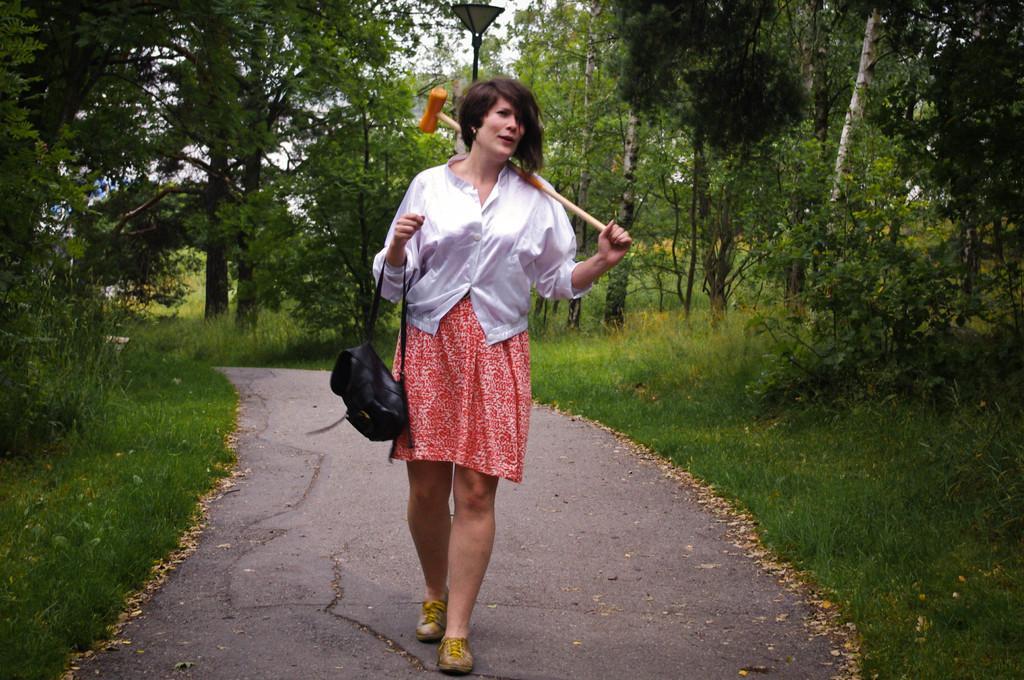Can you describe this image briefly? In the center of the picture there is a woman walking on the road. On the left there are trees, plants, grass and dry leaves. On the right there are trees, plants, grass and dry leaves. In the center of the background there are trees, grass and a street light. 